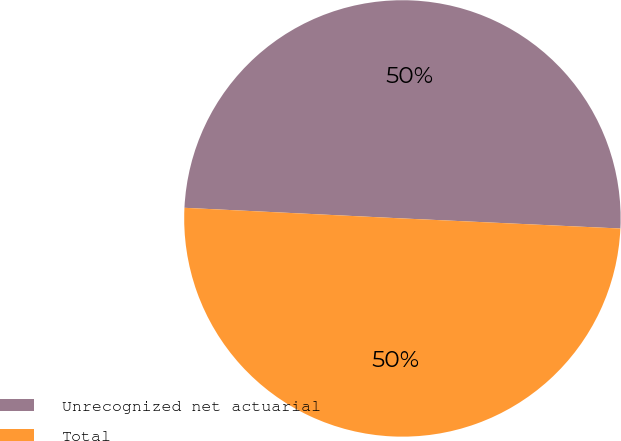Convert chart. <chart><loc_0><loc_0><loc_500><loc_500><pie_chart><fcel>Unrecognized net actuarial<fcel>Total<nl><fcel>49.96%<fcel>50.04%<nl></chart> 